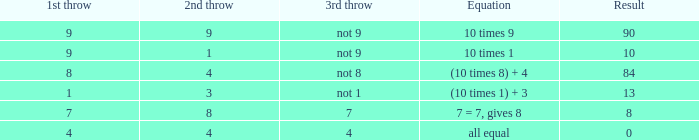What is the equation where the 3rd throw is 7? 7 = 7, gives 8. 